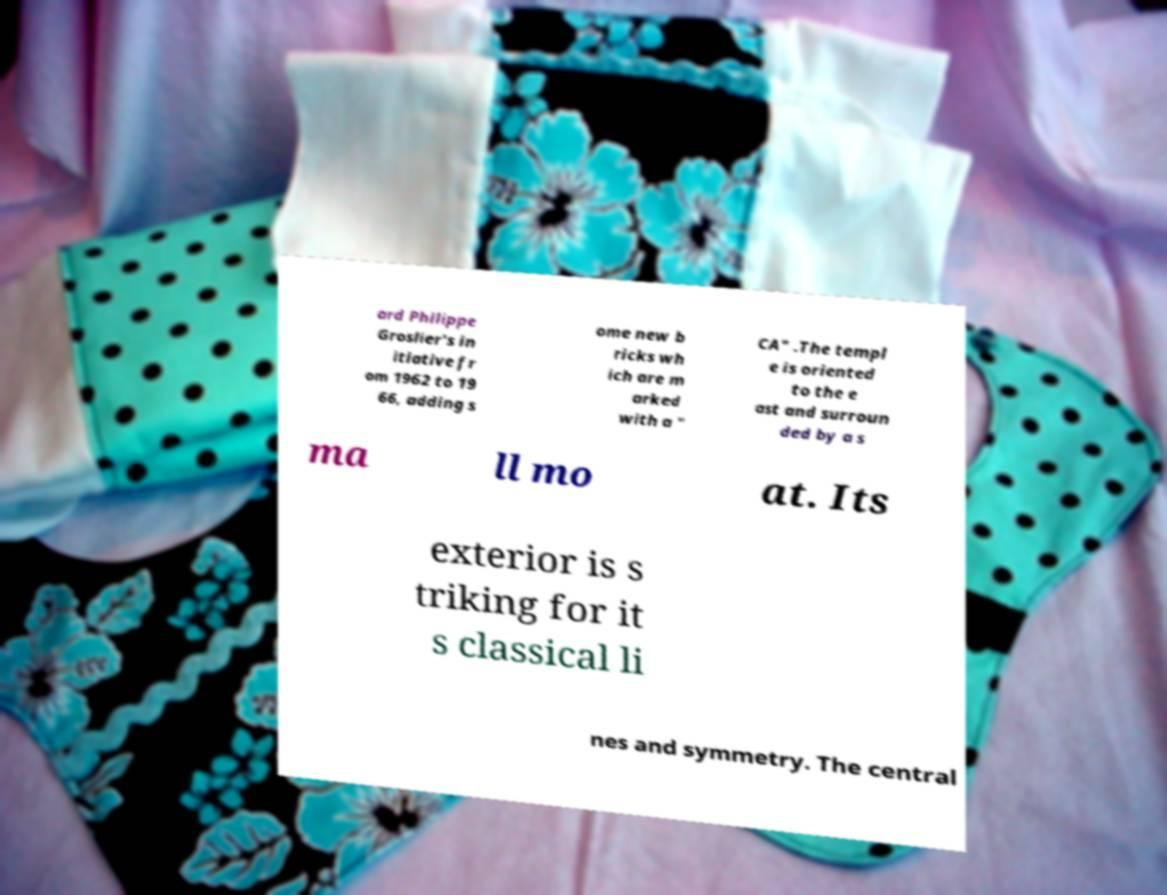Can you read and provide the text displayed in the image?This photo seems to have some interesting text. Can you extract and type it out for me? ard Philippe Groslier's in itiative fr om 1962 to 19 66, adding s ome new b ricks wh ich are m arked with a " CA" .The templ e is oriented to the e ast and surroun ded by a s ma ll mo at. Its exterior is s triking for it s classical li nes and symmetry. The central 